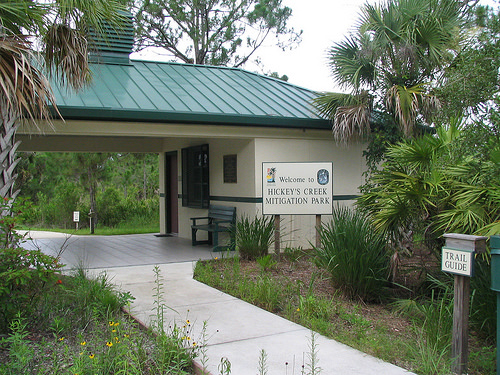<image>
Is the palm tree next to the sign? Yes. The palm tree is positioned adjacent to the sign, located nearby in the same general area. Where is the sign in relation to the path? Is it in front of the path? No. The sign is not in front of the path. The spatial positioning shows a different relationship between these objects. 